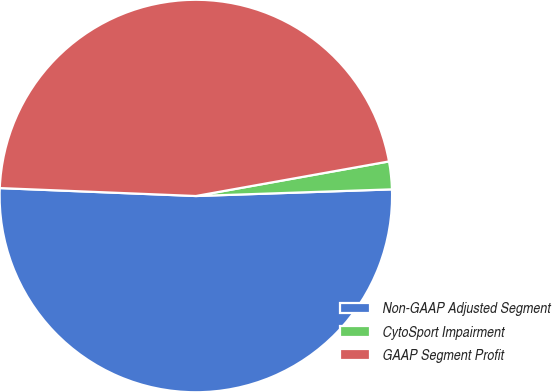Convert chart. <chart><loc_0><loc_0><loc_500><loc_500><pie_chart><fcel>Non-GAAP Adjusted Segment<fcel>CytoSport Impairment<fcel>GAAP Segment Profit<nl><fcel>51.19%<fcel>2.28%<fcel>46.54%<nl></chart> 